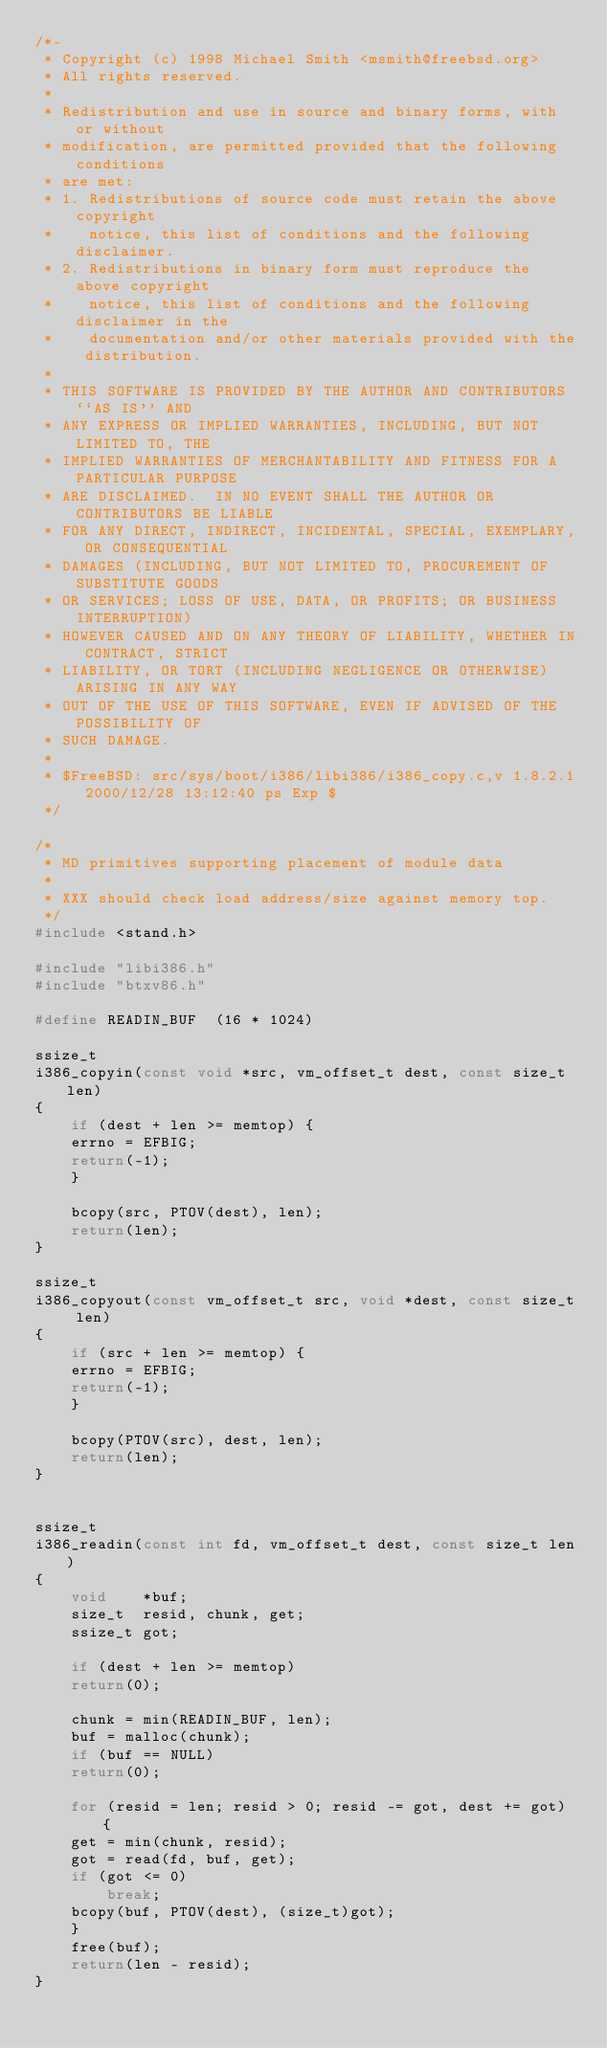Convert code to text. <code><loc_0><loc_0><loc_500><loc_500><_C_>/*-
 * Copyright (c) 1998 Michael Smith <msmith@freebsd.org>
 * All rights reserved.
 *
 * Redistribution and use in source and binary forms, with or without
 * modification, are permitted provided that the following conditions
 * are met:
 * 1. Redistributions of source code must retain the above copyright
 *    notice, this list of conditions and the following disclaimer.
 * 2. Redistributions in binary form must reproduce the above copyright
 *    notice, this list of conditions and the following disclaimer in the
 *    documentation and/or other materials provided with the distribution.
 *
 * THIS SOFTWARE IS PROVIDED BY THE AUTHOR AND CONTRIBUTORS ``AS IS'' AND
 * ANY EXPRESS OR IMPLIED WARRANTIES, INCLUDING, BUT NOT LIMITED TO, THE
 * IMPLIED WARRANTIES OF MERCHANTABILITY AND FITNESS FOR A PARTICULAR PURPOSE
 * ARE DISCLAIMED.  IN NO EVENT SHALL THE AUTHOR OR CONTRIBUTORS BE LIABLE
 * FOR ANY DIRECT, INDIRECT, INCIDENTAL, SPECIAL, EXEMPLARY, OR CONSEQUENTIAL
 * DAMAGES (INCLUDING, BUT NOT LIMITED TO, PROCUREMENT OF SUBSTITUTE GOODS
 * OR SERVICES; LOSS OF USE, DATA, OR PROFITS; OR BUSINESS INTERRUPTION)
 * HOWEVER CAUSED AND ON ANY THEORY OF LIABILITY, WHETHER IN CONTRACT, STRICT
 * LIABILITY, OR TORT (INCLUDING NEGLIGENCE OR OTHERWISE) ARISING IN ANY WAY
 * OUT OF THE USE OF THIS SOFTWARE, EVEN IF ADVISED OF THE POSSIBILITY OF
 * SUCH DAMAGE.
 *
 * $FreeBSD: src/sys/boot/i386/libi386/i386_copy.c,v 1.8.2.1 2000/12/28 13:12:40 ps Exp $
 */

/*
 * MD primitives supporting placement of module data 
 *
 * XXX should check load address/size against memory top.
 */
#include <stand.h>

#include "libi386.h"
#include "btxv86.h"

#define READIN_BUF	(16 * 1024)

ssize_t
i386_copyin(const void *src, vm_offset_t dest, const size_t len)
{
    if (dest + len >= memtop) {
	errno = EFBIG;
	return(-1);
    }

    bcopy(src, PTOV(dest), len);
    return(len);
}

ssize_t
i386_copyout(const vm_offset_t src, void *dest, const size_t len)
{
    if (src + len >= memtop) {
	errno = EFBIG;
	return(-1);
    }
    
    bcopy(PTOV(src), dest, len);
    return(len);
}


ssize_t
i386_readin(const int fd, vm_offset_t dest, const size_t len)
{
    void	*buf;
    size_t	resid, chunk, get;
    ssize_t	got;

    if (dest + len >= memtop)
	return(0);

    chunk = min(READIN_BUF, len);
    buf = malloc(chunk);
    if (buf == NULL)
	return(0);

    for (resid = len; resid > 0; resid -= got, dest += got) {
	get = min(chunk, resid);
	got = read(fd, buf, get);
	if (got <= 0)
	    break;
	bcopy(buf, PTOV(dest), (size_t)got);
    }
    free(buf);
    return(len - resid);
}
</code> 